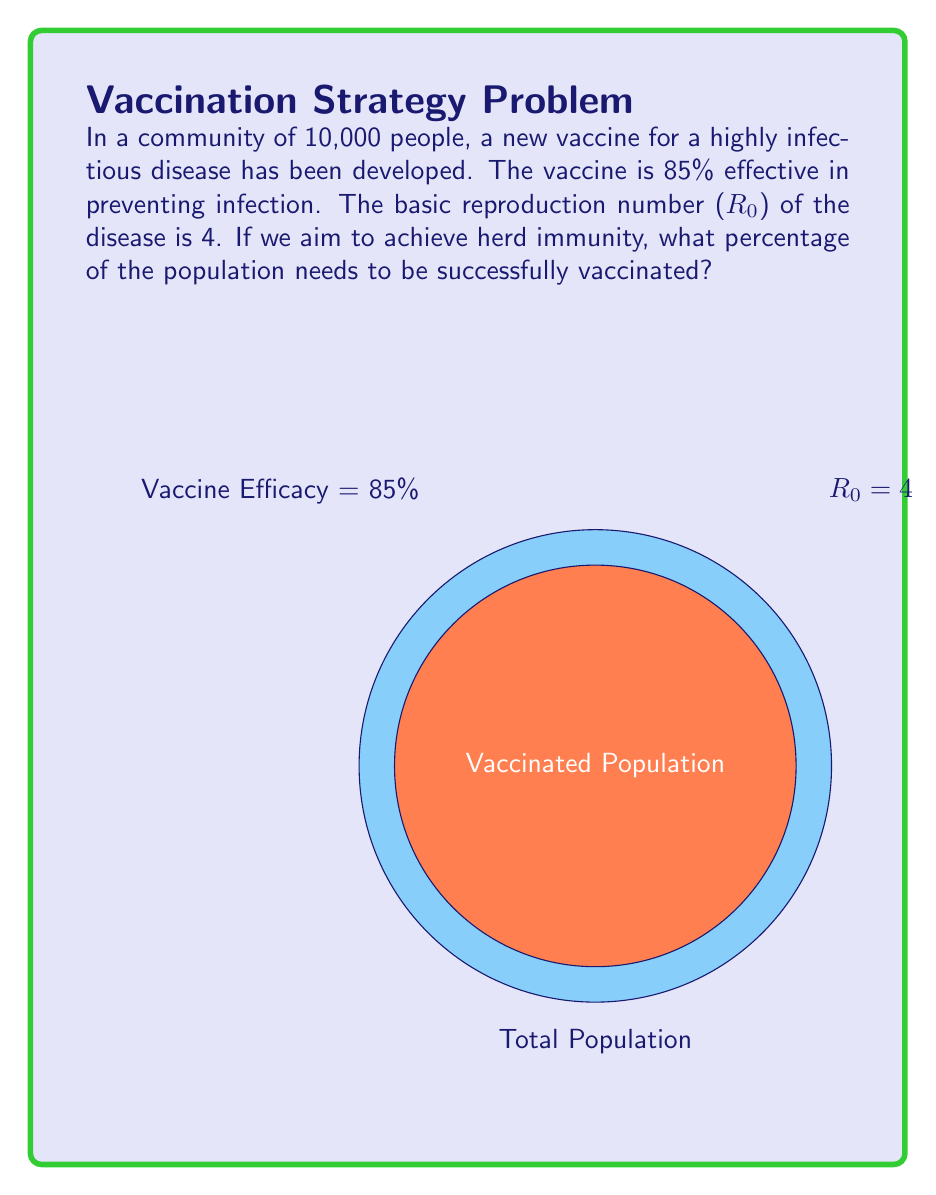Teach me how to tackle this problem. To solve this problem, we'll follow these steps:

1) The herd immunity threshold (HIT) is given by the formula:

   $$ HIT = 1 - \frac{1}{R_0} $$

   where $R_0$ is the basic reproduction number.

2) Substituting $R_0 = 4$:

   $$ HIT = 1 - \frac{1}{4} = 0.75 = 75\% $$

3) However, the vaccine is not 100% effective. We need to account for this in our calculation. If the vaccine is 85% effective, we need to vaccinate more people to achieve the same level of immunity.

4) Let $x$ be the proportion of the population that needs to be vaccinated. Then:

   $$ 0.85x = 0.75 $$

5) Solving for $x$:

   $$ x = \frac{0.75}{0.85} \approx 0.8824 $$

6) Converting to a percentage:

   $$ 0.8824 * 100\% \approx 88.24\% $$

Therefore, approximately 88.24% of the population needs to be vaccinated to achieve herd immunity.
Answer: 88.24% 